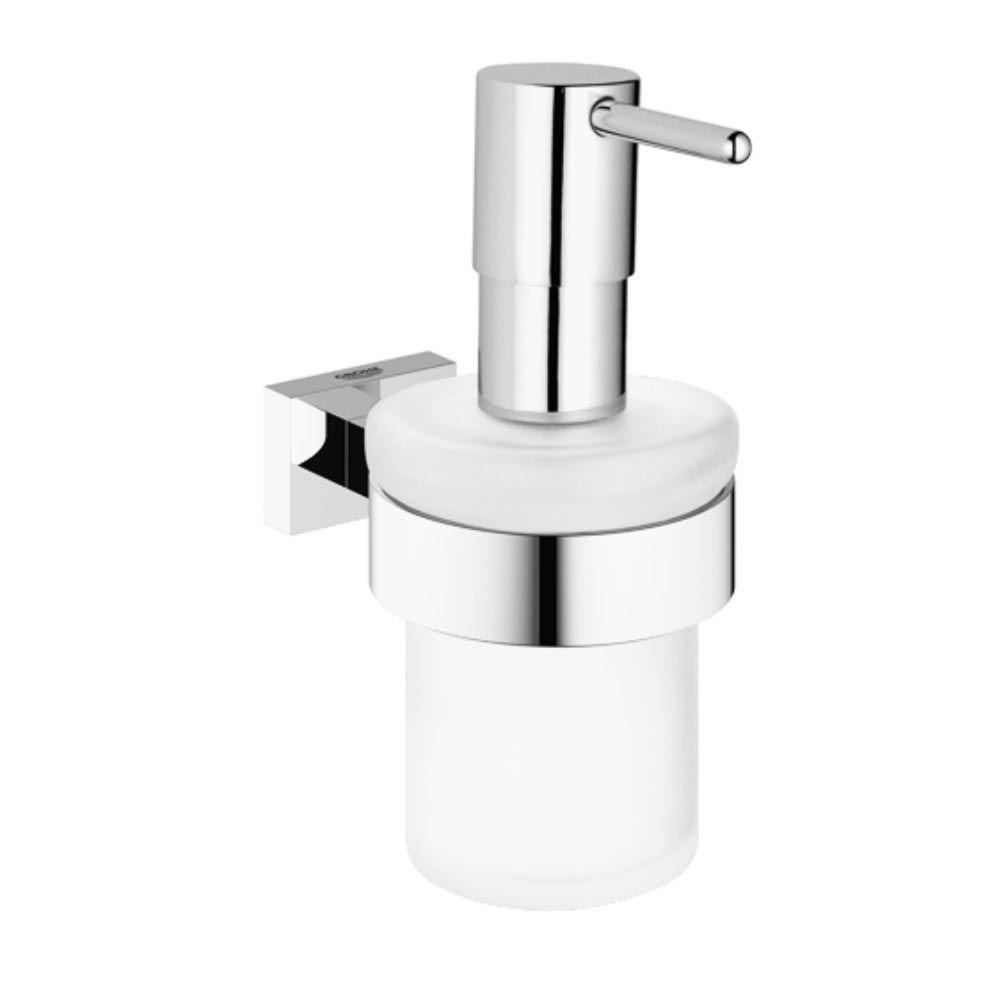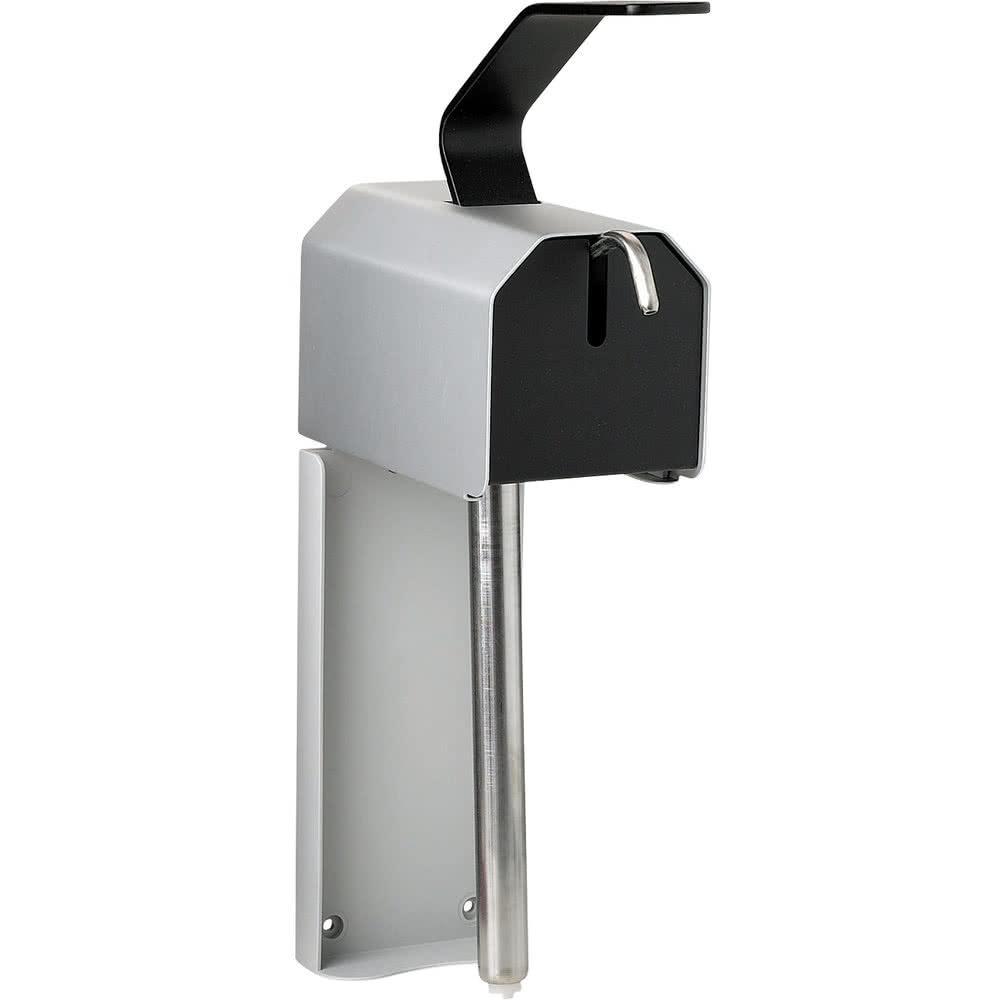The first image is the image on the left, the second image is the image on the right. Examine the images to the left and right. Is the description "Each image contains one cylindrical pump-top dispenser that mounts alone on a wall and has a chrome top and narrow band around it." accurate? Answer yes or no. No. 